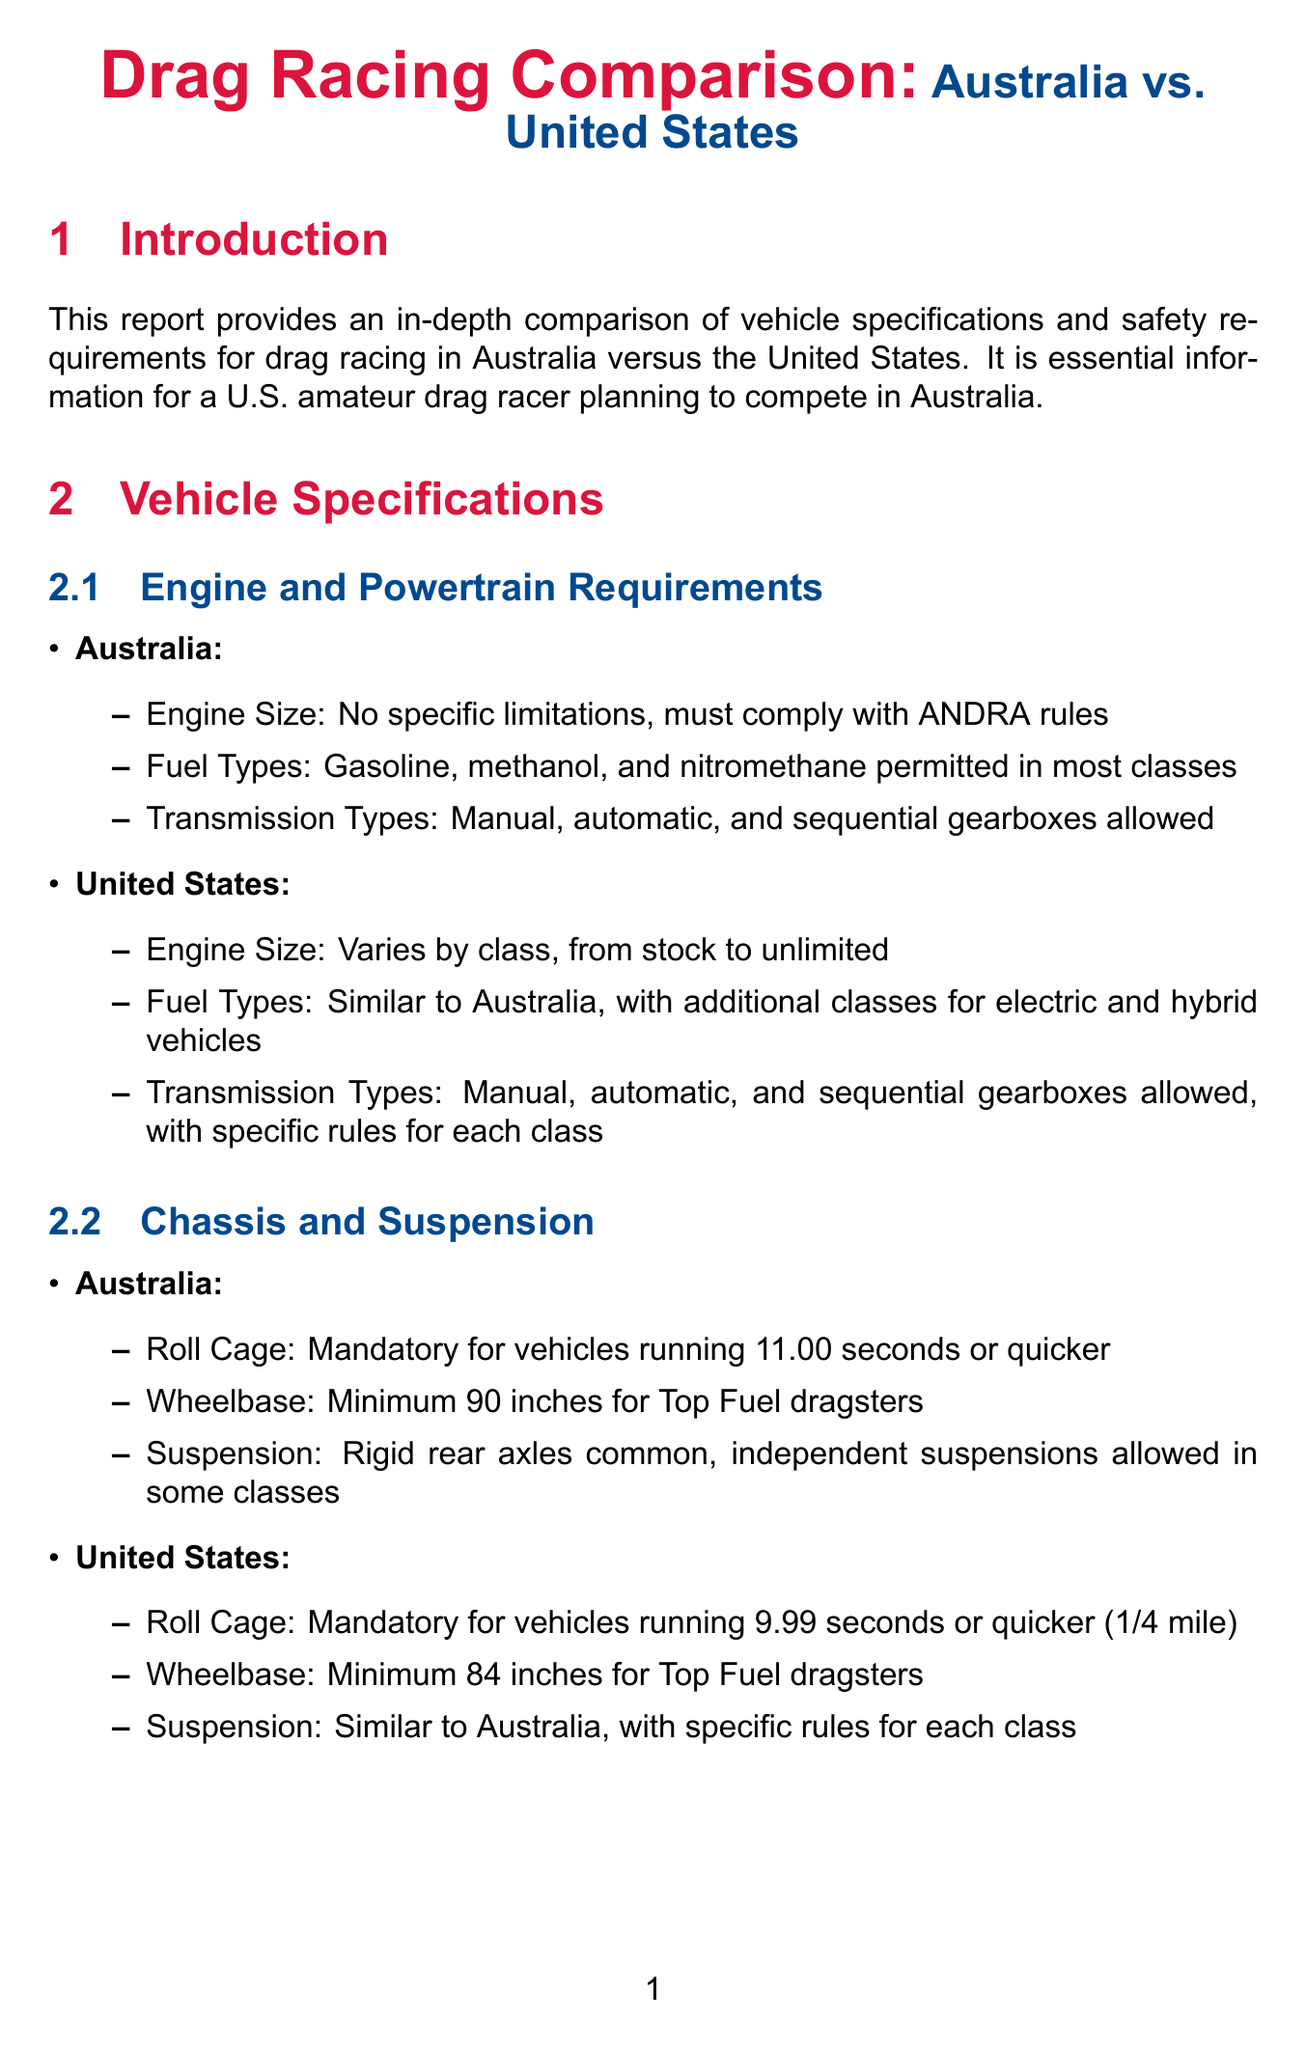What is the engine size requirement in Australia? Australia has no specific limitations on engine size, but it must comply with ANDRA rules.
Answer: No specific limitations What type of fuel is allowed in the U.S.? The U.S. permits fuel types similar to Australia, with additional classes for electric and hybrid vehicles.
Answer: Gasoline, methanol, nitromethane, electric, hybrid What is the minimum wheelbase for Top Fuel dragsters in Australia? The minimum wheelbase for Top Fuel dragsters in Australia is specified in the document.
Answer: 90 inches What helmet certification is required in Australia? The document states that the required helmet certification in Australia is Snell SA2010, SA2015, or FIA 8860-2010.
Answer: Snell SA2010, SA2015, FIA 8860-2010 What safety feature is mandatory for vehicles exceeding 150 mph in both countries? Both Australia and the United States require a specific safety feature for vehicles exceeding 150 mph.
Answer: Parachutes What licensing is needed for racers in Australia? The type of competition license required for racers in Australia is stated in the document.
Answer: ANDRA competition license What is the track preparation compound used in Australia? The document mentions the specific traction compound used for track preparation in Australia.
Answer: VHT TrackBite What is the advice for visiting racers to Australia? The conclusion section provides specific advice for visiting racers before competing in Australia.
Answer: Familiarize with ANDRA rules and obtain necessary licenses 